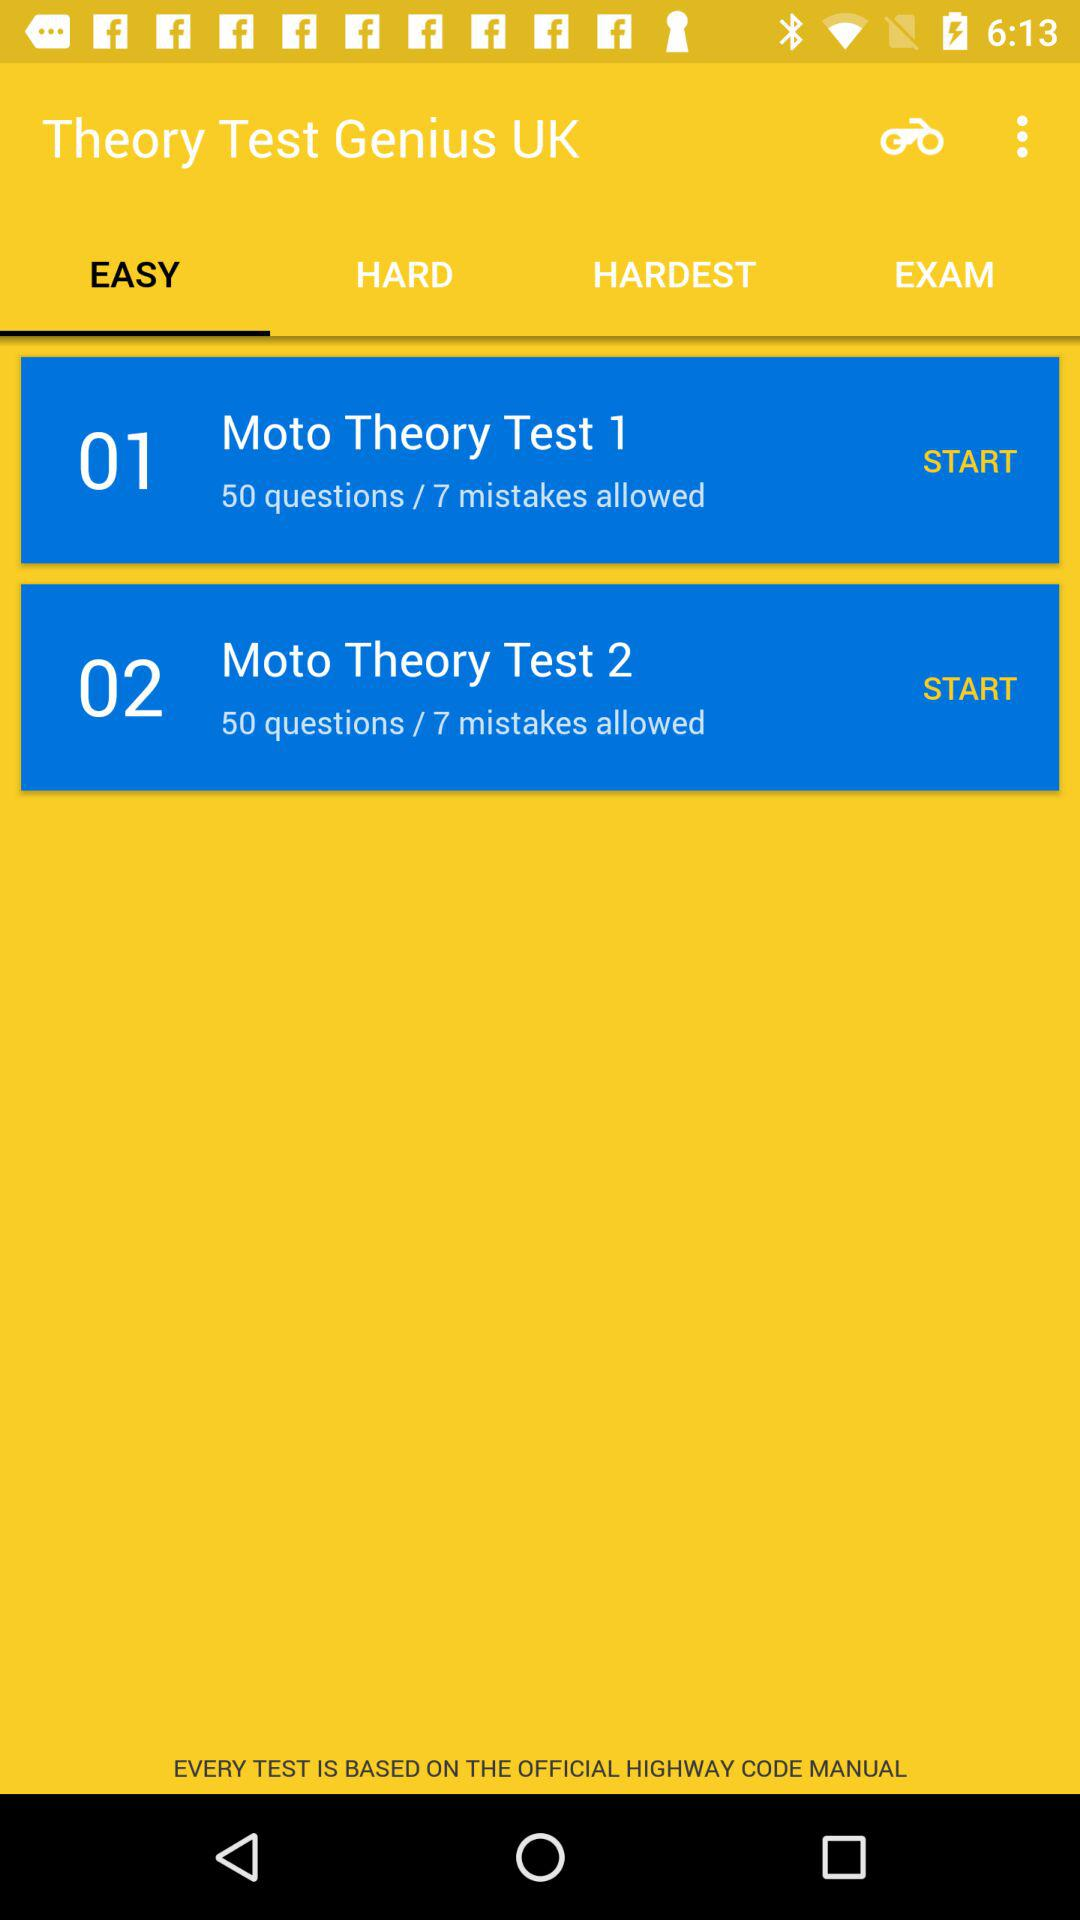How many tests are there in total?
Answer the question using a single word or phrase. 2 